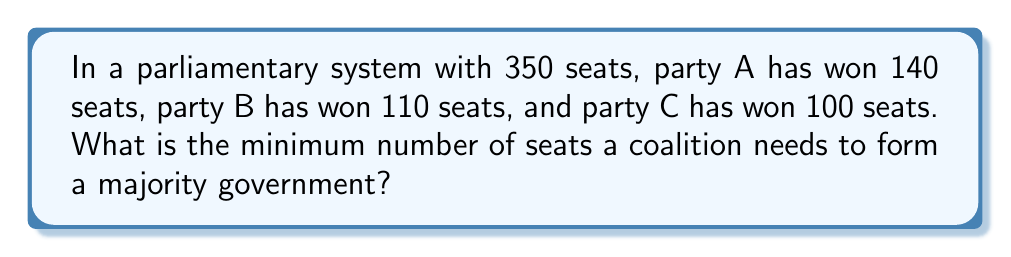Provide a solution to this math problem. To solve this problem, we need to follow these steps:

1. Calculate the total number of seats in the parliament:
   $$ \text{Total seats} = 350 $$

2. Determine the number of seats needed for a majority:
   A majority is defined as more than half of the total seats.
   $$ \text{Majority} = \left\lfloor\frac{\text{Total seats}}{2}\right\rfloor + 1 $$
   $$ \text{Majority} = \left\lfloor\frac{350}{2}\right\rfloor + 1 = 175 + 1 = 176 $$

3. Therefore, any coalition needs at least 176 seats to form a majority government.

This problem relates to political science by illustrating the mathematical basis for forming coalitions in parliamentary systems, which is crucial for understanding government formation and stability in multi-party democracies.
Answer: 176 seats 